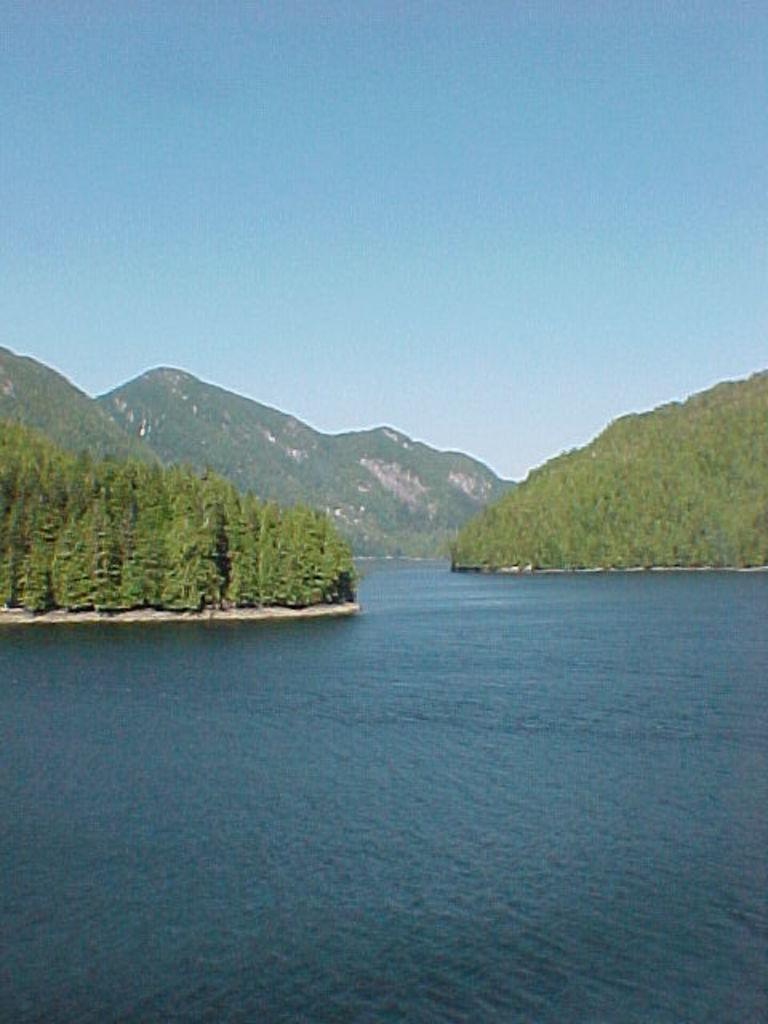Where was the image taken? The image was clicked outside. What can be seen at the bottom of the image? There is water at the bottom of the image. What is present on the left side of the image? There are trees on the left side of the image. What is present on the right side of the image? There are trees on the right side of the image. What can be seen in the background of the image? There is a mountain in the background of the image. What is visible at the top of the image? The sky is visible at the top of the image. How many sisters are visible in the image? There are no sisters present in the image. What is being pulled in the image? There is no object being pulled in the image. 